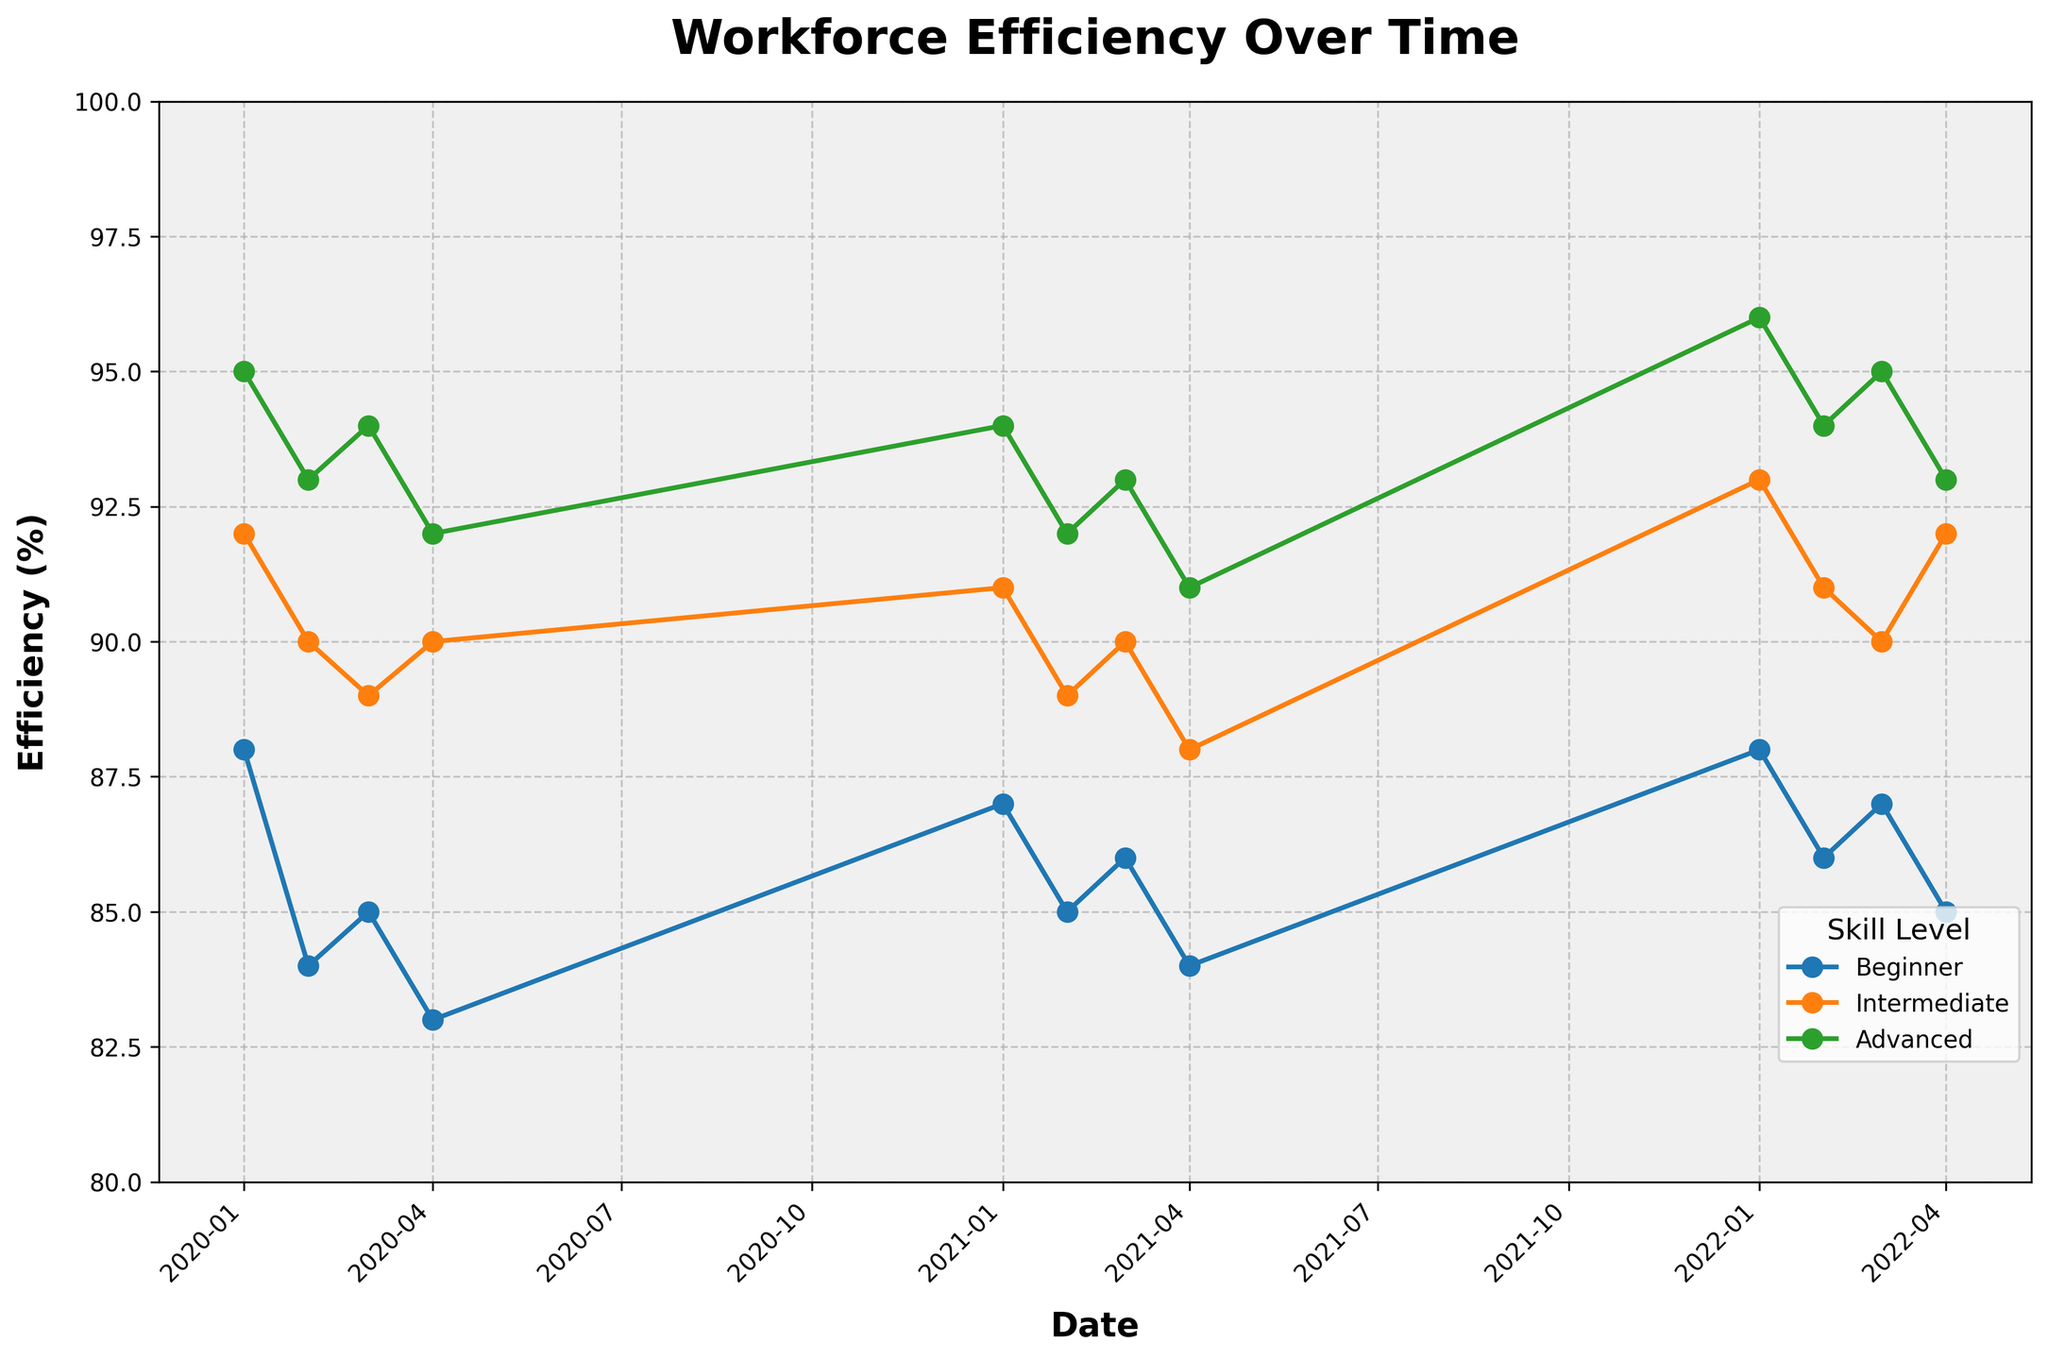What is the title of the plot? The plot's title is prominently displayed at the top of the plot in a larger font compared to other text elements. The title is usually a concise description of what the plot represents.
Answer: Workforce Efficiency Over Time What is the highest recorded efficiency and which skill level and shift does it correspond to? By examining the plot, the highest point on the y-axis represents the highest efficiency. From the graph, it can be observed that the Advanced skill level during the Night shift recorded the highest efficiency.
Answer: 96%, Advanced skill level, Night shift How does the Beginner skill level's efficiency trend over the three-year period? To determine the trend, observe the line representing Beginner skill level across the x-axis (time). The Beginner skill level shows some fluctuations but remains mostly consistent, with efficiencies ranging between 83% and 88%.
Answer: Mostly consistent with slight fluctuation Which year and month recorded the lowest efficiency, and what was the value? To find the lowest efficiency, look for the lowest point on the y-axis. According to the plot, the lowest efficiency is seen in April 2020, for the Beginner skill level at Night shift.
Answer: April 2020, 83% Between Advanced and Intermediate skill levels, which showed more variability in efficiency over the years? Variability can be measured by observing the amplitude of the fluctuations in the lines corresponding to each skill level. From the plot, the Intermediate skill level shows more variability with efficiencies generally ranging from 88% to 93%, while the Advanced skill level is more stable, mainly ranging from 91% to 96%.
Answer: Intermediate skill level On average, does the Day or Night shift yield higher efficiency? To compare, calculate the average efficiency for each shift type across all skill levels and time periods. From the plot, it is observed that the Day shift consistently shows higher efficiencies than the Night shift.
Answer: Day shift What was the efficiency trend for the Intermediate skill level during the month of January over the three years? To detect trends, examine the specific data points corresponding to January for 2020, 2021, and 2022. The Intermediate skill level shows a consistent increase in efficiency during January of each year: 92% in 2020, 91% in 2021, and 93% in 2022.
Answer: Increasing trend Which time period showed the greatest increase in efficiency for the Beginner skill level, and what was the change? To identify periods of significant change, look for the largest vertical jump in the Beginner skill level’s line. The greatest increase is between April 2021 (84%) and January 2022 (88%), a change of 4%.
Answer: April 2021 to January 2022, 4% Is there any month where all three skill levels showed the same efficiency in a particular year? Scan the plot for vertical alignments where all lines meet at the same efficiency value. There is no month depicted in the plot where all three skill levels show the exact same efficiency.
Answer: No Which skills and shifts are most stable, and which are most variable in their efficiency metric over the period? Stability and variability can be gauged by observing the smoothness and amplitude of the lines. Advanced skill level, regardless of shift, appears most stable, while Intermediate skill level, especially during the Night shift, shows more variability.
Answer: Most Stable: Advanced, Most Variable: Intermediate, Night shift 